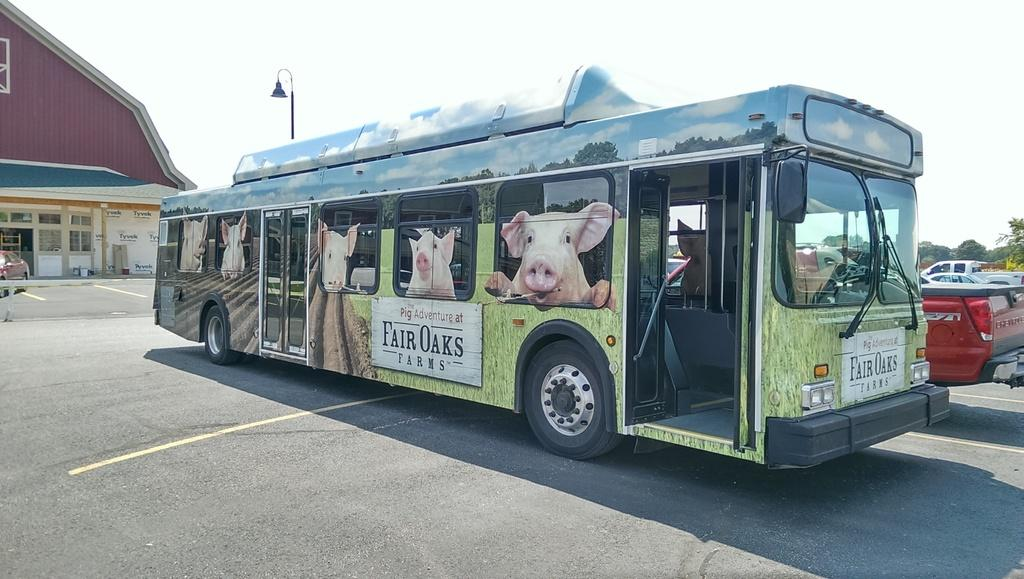What type of vehicle is the main subject of the image? There is a bus in the image. What decorations are on the bus? The bus has pig images on it. What else can be seen in the image besides the bus? There are other vehicles parked in the image, trees, light poles, a house, and the sky is visible in the background. Where is the maid standing with the tray in the image? There is no maid or tray present in the image. How many feet are visible in the image? There is no reference to feet in the image, so it is not possible to determine how many feet are visible. 